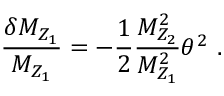<formula> <loc_0><loc_0><loc_500><loc_500>\frac { \delta M _ { Z _ { 1 } } } { M _ { Z _ { 1 } } } = - \frac { 1 } { 2 } \frac { M _ { Z _ { 2 } } ^ { 2 } } { M _ { Z _ { 1 } } ^ { 2 } } \theta ^ { 2 } \ .</formula> 